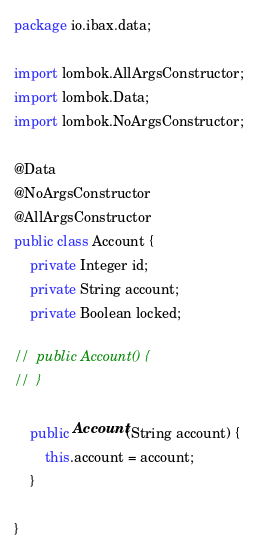Convert code to text. <code><loc_0><loc_0><loc_500><loc_500><_Java_>package io.ibax.data;

import lombok.AllArgsConstructor;
import lombok.Data;
import lombok.NoArgsConstructor;

@Data
@NoArgsConstructor
@AllArgsConstructor
public class Account {
	private Integer id;
	private String account;
	private Boolean locked;

//	public Account() {
//	}

	public Account(String account) {
		this.account = account;
	}

}
</code> 